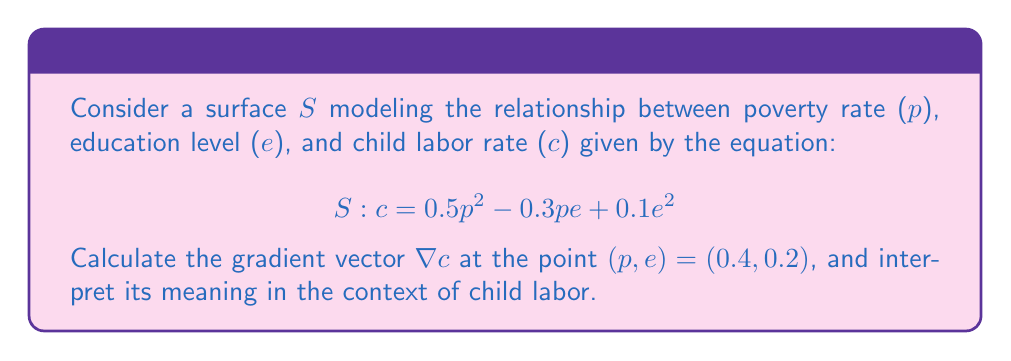Can you solve this math problem? To solve this problem, we'll follow these steps:

1) The gradient of a surface $S: c = f(p,e)$ is given by:

   $$\nabla c = \left(\frac{\partial c}{\partial p}, \frac{\partial c}{\partial e}\right)$$

2) Calculate $\frac{\partial c}{\partial p}$:
   $$\frac{\partial c}{\partial p} = p - 0.3e$$

3) Calculate $\frac{\partial c}{\partial e}$:
   $$\frac{\partial c}{\partial e} = -0.3p + 0.2e$$

4) Now we have the gradient vector:
   $$\nabla c = (p - 0.3e, -0.3p + 0.2e)$$

5) Evaluate at the point $(p, e) = (0.4, 0.2)$:
   $$\nabla c = (0.4 - 0.3(0.2), -0.3(0.4) + 0.2(0.2))$$
   $$\nabla c = (0.34, -0.08)$$

6) Interpretation:
   - The partial derivative with respect to $p$ (0.34) is positive, indicating that as poverty increases, child labor tends to increase.
   - The partial derivative with respect to $e$ (-0.08) is negative, suggesting that as education level increases, child labor tends to decrease.
   - The magnitude of the poverty effect (0.34) is larger than the education effect (-0.08), implying that poverty has a stronger influence on child labor at this point.

This gradient aligns with the experience of many child laborers, where poverty often forces children to work instead of attending school, perpetuating the cycle of poverty and limited education.
Answer: $\nabla c = (0.34, -0.08)$ 